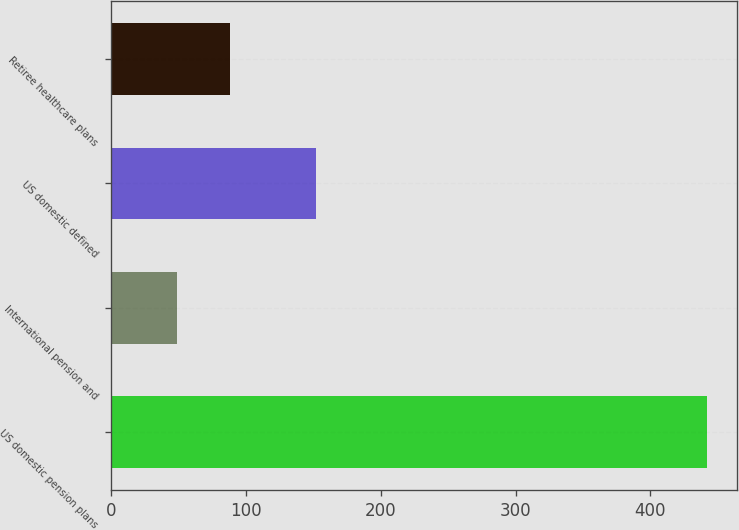Convert chart to OTSL. <chart><loc_0><loc_0><loc_500><loc_500><bar_chart><fcel>US domestic pension plans<fcel>International pension and<fcel>US domestic defined<fcel>Retiree healthcare plans<nl><fcel>442<fcel>49<fcel>152<fcel>88.3<nl></chart> 